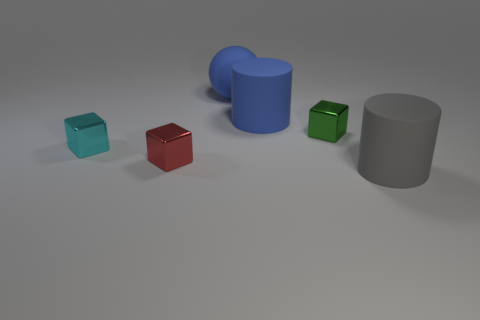What material is the cyan thing that is the same shape as the small red thing?
Offer a terse response. Metal. Is there anything else that has the same material as the tiny green cube?
Keep it short and to the point. Yes. There is a small red object; are there any big gray matte cylinders left of it?
Offer a terse response. No. How many cyan cubes are there?
Your answer should be very brief. 1. There is a tiny thing left of the red shiny block; how many tiny green metallic cubes are in front of it?
Provide a succinct answer. 0. There is a big rubber ball; does it have the same color as the small thing that is to the right of the ball?
Provide a short and direct response. No. How many gray things are the same shape as the red metal thing?
Provide a short and direct response. 0. What is the material of the cube on the right side of the small red thing?
Give a very brief answer. Metal. There is a small object that is on the right side of the blue matte cylinder; does it have the same shape as the gray thing?
Your answer should be very brief. No. Is there a purple matte block that has the same size as the gray rubber object?
Give a very brief answer. No. 